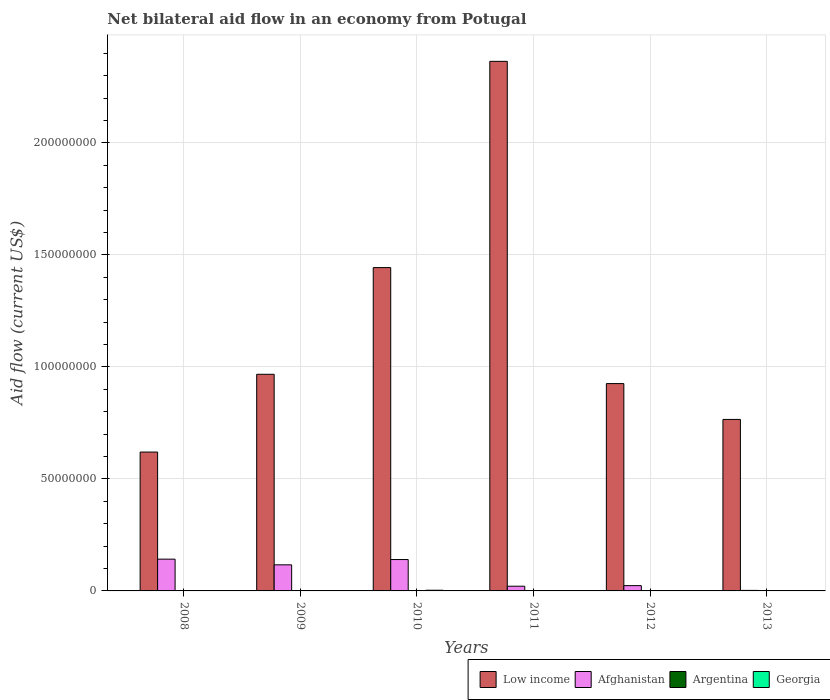How many different coloured bars are there?
Offer a very short reply. 4. Are the number of bars on each tick of the X-axis equal?
Ensure brevity in your answer.  Yes. How many bars are there on the 1st tick from the right?
Make the answer very short. 4. Across all years, what is the maximum net bilateral aid flow in Low income?
Ensure brevity in your answer.  2.36e+08. Across all years, what is the minimum net bilateral aid flow in Afghanistan?
Provide a short and direct response. 2.30e+05. In which year was the net bilateral aid flow in Low income maximum?
Your response must be concise. 2011. In which year was the net bilateral aid flow in Georgia minimum?
Your answer should be compact. 2012. What is the total net bilateral aid flow in Afghanistan in the graph?
Offer a very short reply. 4.45e+07. What is the difference between the net bilateral aid flow in Afghanistan in 2008 and that in 2013?
Offer a very short reply. 1.40e+07. What is the difference between the net bilateral aid flow in Georgia in 2012 and the net bilateral aid flow in Low income in 2013?
Offer a very short reply. -7.65e+07. What is the average net bilateral aid flow in Afghanistan per year?
Offer a terse response. 7.42e+06. In the year 2012, what is the difference between the net bilateral aid flow in Low income and net bilateral aid flow in Afghanistan?
Ensure brevity in your answer.  9.02e+07. What is the ratio of the net bilateral aid flow in Argentina in 2009 to that in 2010?
Keep it short and to the point. 2.25. What is the difference between the highest and the second highest net bilateral aid flow in Low income?
Your answer should be compact. 9.20e+07. What is the difference between the highest and the lowest net bilateral aid flow in Argentina?
Your answer should be very brief. 8.00e+04. What does the 4th bar from the left in 2010 represents?
Provide a succinct answer. Georgia. What does the 1st bar from the right in 2010 represents?
Your answer should be compact. Georgia. Are all the bars in the graph horizontal?
Your response must be concise. No. How many years are there in the graph?
Offer a very short reply. 6. Does the graph contain any zero values?
Provide a succinct answer. No. Does the graph contain grids?
Offer a very short reply. Yes. Where does the legend appear in the graph?
Your answer should be very brief. Bottom right. What is the title of the graph?
Provide a short and direct response. Net bilateral aid flow in an economy from Potugal. Does "Aruba" appear as one of the legend labels in the graph?
Make the answer very short. No. What is the label or title of the Y-axis?
Your answer should be very brief. Aid flow (current US$). What is the Aid flow (current US$) in Low income in 2008?
Give a very brief answer. 6.20e+07. What is the Aid flow (current US$) in Afghanistan in 2008?
Give a very brief answer. 1.42e+07. What is the Aid flow (current US$) of Argentina in 2008?
Your answer should be compact. 1.20e+05. What is the Aid flow (current US$) of Georgia in 2008?
Offer a terse response. 1.00e+05. What is the Aid flow (current US$) in Low income in 2009?
Keep it short and to the point. 9.67e+07. What is the Aid flow (current US$) of Afghanistan in 2009?
Your answer should be compact. 1.16e+07. What is the Aid flow (current US$) of Low income in 2010?
Keep it short and to the point. 1.44e+08. What is the Aid flow (current US$) of Afghanistan in 2010?
Your answer should be very brief. 1.40e+07. What is the Aid flow (current US$) in Argentina in 2010?
Provide a succinct answer. 4.00e+04. What is the Aid flow (current US$) of Georgia in 2010?
Your answer should be very brief. 3.00e+05. What is the Aid flow (current US$) in Low income in 2011?
Make the answer very short. 2.36e+08. What is the Aid flow (current US$) in Afghanistan in 2011?
Provide a succinct answer. 2.10e+06. What is the Aid flow (current US$) of Argentina in 2011?
Your answer should be very brief. 1.00e+05. What is the Aid flow (current US$) of Georgia in 2011?
Provide a short and direct response. 1.00e+05. What is the Aid flow (current US$) in Low income in 2012?
Your response must be concise. 9.25e+07. What is the Aid flow (current US$) of Afghanistan in 2012?
Provide a short and direct response. 2.36e+06. What is the Aid flow (current US$) of Georgia in 2012?
Keep it short and to the point. 5.00e+04. What is the Aid flow (current US$) of Low income in 2013?
Offer a very short reply. 7.65e+07. What is the Aid flow (current US$) in Afghanistan in 2013?
Your answer should be compact. 2.30e+05. What is the Aid flow (current US$) of Argentina in 2013?
Your response must be concise. 1.20e+05. Across all years, what is the maximum Aid flow (current US$) of Low income?
Provide a short and direct response. 2.36e+08. Across all years, what is the maximum Aid flow (current US$) of Afghanistan?
Give a very brief answer. 1.42e+07. Across all years, what is the maximum Aid flow (current US$) in Argentina?
Offer a very short reply. 1.20e+05. Across all years, what is the minimum Aid flow (current US$) of Low income?
Offer a very short reply. 6.20e+07. Across all years, what is the minimum Aid flow (current US$) in Afghanistan?
Offer a very short reply. 2.30e+05. Across all years, what is the minimum Aid flow (current US$) of Argentina?
Your answer should be compact. 4.00e+04. What is the total Aid flow (current US$) of Low income in the graph?
Give a very brief answer. 7.08e+08. What is the total Aid flow (current US$) of Afghanistan in the graph?
Your answer should be very brief. 4.45e+07. What is the total Aid flow (current US$) of Georgia in the graph?
Your response must be concise. 8.10e+05. What is the difference between the Aid flow (current US$) in Low income in 2008 and that in 2009?
Offer a very short reply. -3.47e+07. What is the difference between the Aid flow (current US$) in Afghanistan in 2008 and that in 2009?
Ensure brevity in your answer.  2.54e+06. What is the difference between the Aid flow (current US$) of Argentina in 2008 and that in 2009?
Ensure brevity in your answer.  3.00e+04. What is the difference between the Aid flow (current US$) in Low income in 2008 and that in 2010?
Your answer should be very brief. -8.23e+07. What is the difference between the Aid flow (current US$) of Georgia in 2008 and that in 2010?
Give a very brief answer. -2.00e+05. What is the difference between the Aid flow (current US$) of Low income in 2008 and that in 2011?
Offer a very short reply. -1.74e+08. What is the difference between the Aid flow (current US$) of Afghanistan in 2008 and that in 2011?
Offer a terse response. 1.21e+07. What is the difference between the Aid flow (current US$) in Argentina in 2008 and that in 2011?
Your answer should be compact. 2.00e+04. What is the difference between the Aid flow (current US$) in Georgia in 2008 and that in 2011?
Offer a very short reply. 0. What is the difference between the Aid flow (current US$) of Low income in 2008 and that in 2012?
Keep it short and to the point. -3.06e+07. What is the difference between the Aid flow (current US$) in Afghanistan in 2008 and that in 2012?
Make the answer very short. 1.18e+07. What is the difference between the Aid flow (current US$) in Argentina in 2008 and that in 2012?
Your response must be concise. 4.00e+04. What is the difference between the Aid flow (current US$) in Low income in 2008 and that in 2013?
Offer a very short reply. -1.46e+07. What is the difference between the Aid flow (current US$) of Afghanistan in 2008 and that in 2013?
Your answer should be very brief. 1.40e+07. What is the difference between the Aid flow (current US$) in Argentina in 2008 and that in 2013?
Give a very brief answer. 0. What is the difference between the Aid flow (current US$) in Low income in 2009 and that in 2010?
Keep it short and to the point. -4.76e+07. What is the difference between the Aid flow (current US$) in Afghanistan in 2009 and that in 2010?
Offer a terse response. -2.37e+06. What is the difference between the Aid flow (current US$) of Low income in 2009 and that in 2011?
Your answer should be very brief. -1.40e+08. What is the difference between the Aid flow (current US$) in Afghanistan in 2009 and that in 2011?
Your answer should be very brief. 9.54e+06. What is the difference between the Aid flow (current US$) of Argentina in 2009 and that in 2011?
Your answer should be compact. -10000. What is the difference between the Aid flow (current US$) of Low income in 2009 and that in 2012?
Give a very brief answer. 4.15e+06. What is the difference between the Aid flow (current US$) of Afghanistan in 2009 and that in 2012?
Offer a very short reply. 9.28e+06. What is the difference between the Aid flow (current US$) of Low income in 2009 and that in 2013?
Ensure brevity in your answer.  2.02e+07. What is the difference between the Aid flow (current US$) of Afghanistan in 2009 and that in 2013?
Keep it short and to the point. 1.14e+07. What is the difference between the Aid flow (current US$) in Argentina in 2009 and that in 2013?
Give a very brief answer. -3.00e+04. What is the difference between the Aid flow (current US$) of Georgia in 2009 and that in 2013?
Ensure brevity in your answer.  -4.00e+04. What is the difference between the Aid flow (current US$) of Low income in 2010 and that in 2011?
Make the answer very short. -9.20e+07. What is the difference between the Aid flow (current US$) in Afghanistan in 2010 and that in 2011?
Provide a short and direct response. 1.19e+07. What is the difference between the Aid flow (current US$) in Argentina in 2010 and that in 2011?
Your answer should be compact. -6.00e+04. What is the difference between the Aid flow (current US$) in Low income in 2010 and that in 2012?
Provide a succinct answer. 5.18e+07. What is the difference between the Aid flow (current US$) of Afghanistan in 2010 and that in 2012?
Keep it short and to the point. 1.16e+07. What is the difference between the Aid flow (current US$) in Argentina in 2010 and that in 2012?
Make the answer very short. -4.00e+04. What is the difference between the Aid flow (current US$) in Low income in 2010 and that in 2013?
Provide a short and direct response. 6.78e+07. What is the difference between the Aid flow (current US$) in Afghanistan in 2010 and that in 2013?
Your answer should be compact. 1.38e+07. What is the difference between the Aid flow (current US$) of Georgia in 2010 and that in 2013?
Make the answer very short. 1.50e+05. What is the difference between the Aid flow (current US$) in Low income in 2011 and that in 2012?
Your answer should be very brief. 1.44e+08. What is the difference between the Aid flow (current US$) in Afghanistan in 2011 and that in 2012?
Make the answer very short. -2.60e+05. What is the difference between the Aid flow (current US$) of Georgia in 2011 and that in 2012?
Give a very brief answer. 5.00e+04. What is the difference between the Aid flow (current US$) in Low income in 2011 and that in 2013?
Keep it short and to the point. 1.60e+08. What is the difference between the Aid flow (current US$) of Afghanistan in 2011 and that in 2013?
Your response must be concise. 1.87e+06. What is the difference between the Aid flow (current US$) in Georgia in 2011 and that in 2013?
Give a very brief answer. -5.00e+04. What is the difference between the Aid flow (current US$) in Low income in 2012 and that in 2013?
Make the answer very short. 1.60e+07. What is the difference between the Aid flow (current US$) of Afghanistan in 2012 and that in 2013?
Provide a short and direct response. 2.13e+06. What is the difference between the Aid flow (current US$) of Argentina in 2012 and that in 2013?
Keep it short and to the point. -4.00e+04. What is the difference between the Aid flow (current US$) of Low income in 2008 and the Aid flow (current US$) of Afghanistan in 2009?
Your response must be concise. 5.03e+07. What is the difference between the Aid flow (current US$) of Low income in 2008 and the Aid flow (current US$) of Argentina in 2009?
Offer a very short reply. 6.19e+07. What is the difference between the Aid flow (current US$) of Low income in 2008 and the Aid flow (current US$) of Georgia in 2009?
Ensure brevity in your answer.  6.19e+07. What is the difference between the Aid flow (current US$) in Afghanistan in 2008 and the Aid flow (current US$) in Argentina in 2009?
Your response must be concise. 1.41e+07. What is the difference between the Aid flow (current US$) of Afghanistan in 2008 and the Aid flow (current US$) of Georgia in 2009?
Make the answer very short. 1.41e+07. What is the difference between the Aid flow (current US$) of Low income in 2008 and the Aid flow (current US$) of Afghanistan in 2010?
Your answer should be very brief. 4.80e+07. What is the difference between the Aid flow (current US$) in Low income in 2008 and the Aid flow (current US$) in Argentina in 2010?
Your response must be concise. 6.19e+07. What is the difference between the Aid flow (current US$) in Low income in 2008 and the Aid flow (current US$) in Georgia in 2010?
Offer a very short reply. 6.17e+07. What is the difference between the Aid flow (current US$) in Afghanistan in 2008 and the Aid flow (current US$) in Argentina in 2010?
Provide a short and direct response. 1.41e+07. What is the difference between the Aid flow (current US$) of Afghanistan in 2008 and the Aid flow (current US$) of Georgia in 2010?
Ensure brevity in your answer.  1.39e+07. What is the difference between the Aid flow (current US$) in Argentina in 2008 and the Aid flow (current US$) in Georgia in 2010?
Your answer should be compact. -1.80e+05. What is the difference between the Aid flow (current US$) in Low income in 2008 and the Aid flow (current US$) in Afghanistan in 2011?
Ensure brevity in your answer.  5.99e+07. What is the difference between the Aid flow (current US$) of Low income in 2008 and the Aid flow (current US$) of Argentina in 2011?
Offer a very short reply. 6.19e+07. What is the difference between the Aid flow (current US$) in Low income in 2008 and the Aid flow (current US$) in Georgia in 2011?
Make the answer very short. 6.19e+07. What is the difference between the Aid flow (current US$) of Afghanistan in 2008 and the Aid flow (current US$) of Argentina in 2011?
Give a very brief answer. 1.41e+07. What is the difference between the Aid flow (current US$) of Afghanistan in 2008 and the Aid flow (current US$) of Georgia in 2011?
Make the answer very short. 1.41e+07. What is the difference between the Aid flow (current US$) of Low income in 2008 and the Aid flow (current US$) of Afghanistan in 2012?
Make the answer very short. 5.96e+07. What is the difference between the Aid flow (current US$) of Low income in 2008 and the Aid flow (current US$) of Argentina in 2012?
Offer a terse response. 6.19e+07. What is the difference between the Aid flow (current US$) in Low income in 2008 and the Aid flow (current US$) in Georgia in 2012?
Your response must be concise. 6.19e+07. What is the difference between the Aid flow (current US$) of Afghanistan in 2008 and the Aid flow (current US$) of Argentina in 2012?
Keep it short and to the point. 1.41e+07. What is the difference between the Aid flow (current US$) in Afghanistan in 2008 and the Aid flow (current US$) in Georgia in 2012?
Make the answer very short. 1.41e+07. What is the difference between the Aid flow (current US$) of Low income in 2008 and the Aid flow (current US$) of Afghanistan in 2013?
Provide a succinct answer. 6.18e+07. What is the difference between the Aid flow (current US$) in Low income in 2008 and the Aid flow (current US$) in Argentina in 2013?
Your answer should be very brief. 6.19e+07. What is the difference between the Aid flow (current US$) of Low income in 2008 and the Aid flow (current US$) of Georgia in 2013?
Provide a short and direct response. 6.18e+07. What is the difference between the Aid flow (current US$) of Afghanistan in 2008 and the Aid flow (current US$) of Argentina in 2013?
Offer a very short reply. 1.41e+07. What is the difference between the Aid flow (current US$) of Afghanistan in 2008 and the Aid flow (current US$) of Georgia in 2013?
Your answer should be very brief. 1.40e+07. What is the difference between the Aid flow (current US$) in Low income in 2009 and the Aid flow (current US$) in Afghanistan in 2010?
Ensure brevity in your answer.  8.27e+07. What is the difference between the Aid flow (current US$) of Low income in 2009 and the Aid flow (current US$) of Argentina in 2010?
Give a very brief answer. 9.66e+07. What is the difference between the Aid flow (current US$) of Low income in 2009 and the Aid flow (current US$) of Georgia in 2010?
Provide a short and direct response. 9.64e+07. What is the difference between the Aid flow (current US$) of Afghanistan in 2009 and the Aid flow (current US$) of Argentina in 2010?
Make the answer very short. 1.16e+07. What is the difference between the Aid flow (current US$) of Afghanistan in 2009 and the Aid flow (current US$) of Georgia in 2010?
Provide a succinct answer. 1.13e+07. What is the difference between the Aid flow (current US$) in Low income in 2009 and the Aid flow (current US$) in Afghanistan in 2011?
Make the answer very short. 9.46e+07. What is the difference between the Aid flow (current US$) of Low income in 2009 and the Aid flow (current US$) of Argentina in 2011?
Give a very brief answer. 9.66e+07. What is the difference between the Aid flow (current US$) of Low income in 2009 and the Aid flow (current US$) of Georgia in 2011?
Offer a very short reply. 9.66e+07. What is the difference between the Aid flow (current US$) in Afghanistan in 2009 and the Aid flow (current US$) in Argentina in 2011?
Provide a short and direct response. 1.15e+07. What is the difference between the Aid flow (current US$) of Afghanistan in 2009 and the Aid flow (current US$) of Georgia in 2011?
Your response must be concise. 1.15e+07. What is the difference between the Aid flow (current US$) in Argentina in 2009 and the Aid flow (current US$) in Georgia in 2011?
Ensure brevity in your answer.  -10000. What is the difference between the Aid flow (current US$) in Low income in 2009 and the Aid flow (current US$) in Afghanistan in 2012?
Your answer should be very brief. 9.43e+07. What is the difference between the Aid flow (current US$) of Low income in 2009 and the Aid flow (current US$) of Argentina in 2012?
Give a very brief answer. 9.66e+07. What is the difference between the Aid flow (current US$) in Low income in 2009 and the Aid flow (current US$) in Georgia in 2012?
Provide a short and direct response. 9.66e+07. What is the difference between the Aid flow (current US$) in Afghanistan in 2009 and the Aid flow (current US$) in Argentina in 2012?
Ensure brevity in your answer.  1.16e+07. What is the difference between the Aid flow (current US$) of Afghanistan in 2009 and the Aid flow (current US$) of Georgia in 2012?
Your answer should be compact. 1.16e+07. What is the difference between the Aid flow (current US$) in Argentina in 2009 and the Aid flow (current US$) in Georgia in 2012?
Provide a succinct answer. 4.00e+04. What is the difference between the Aid flow (current US$) of Low income in 2009 and the Aid flow (current US$) of Afghanistan in 2013?
Provide a short and direct response. 9.65e+07. What is the difference between the Aid flow (current US$) in Low income in 2009 and the Aid flow (current US$) in Argentina in 2013?
Make the answer very short. 9.66e+07. What is the difference between the Aid flow (current US$) in Low income in 2009 and the Aid flow (current US$) in Georgia in 2013?
Offer a very short reply. 9.65e+07. What is the difference between the Aid flow (current US$) of Afghanistan in 2009 and the Aid flow (current US$) of Argentina in 2013?
Give a very brief answer. 1.15e+07. What is the difference between the Aid flow (current US$) of Afghanistan in 2009 and the Aid flow (current US$) of Georgia in 2013?
Your answer should be very brief. 1.15e+07. What is the difference between the Aid flow (current US$) of Argentina in 2009 and the Aid flow (current US$) of Georgia in 2013?
Provide a succinct answer. -6.00e+04. What is the difference between the Aid flow (current US$) in Low income in 2010 and the Aid flow (current US$) in Afghanistan in 2011?
Keep it short and to the point. 1.42e+08. What is the difference between the Aid flow (current US$) in Low income in 2010 and the Aid flow (current US$) in Argentina in 2011?
Provide a succinct answer. 1.44e+08. What is the difference between the Aid flow (current US$) in Low income in 2010 and the Aid flow (current US$) in Georgia in 2011?
Ensure brevity in your answer.  1.44e+08. What is the difference between the Aid flow (current US$) of Afghanistan in 2010 and the Aid flow (current US$) of Argentina in 2011?
Give a very brief answer. 1.39e+07. What is the difference between the Aid flow (current US$) of Afghanistan in 2010 and the Aid flow (current US$) of Georgia in 2011?
Make the answer very short. 1.39e+07. What is the difference between the Aid flow (current US$) in Argentina in 2010 and the Aid flow (current US$) in Georgia in 2011?
Offer a terse response. -6.00e+04. What is the difference between the Aid flow (current US$) in Low income in 2010 and the Aid flow (current US$) in Afghanistan in 2012?
Offer a terse response. 1.42e+08. What is the difference between the Aid flow (current US$) in Low income in 2010 and the Aid flow (current US$) in Argentina in 2012?
Provide a short and direct response. 1.44e+08. What is the difference between the Aid flow (current US$) in Low income in 2010 and the Aid flow (current US$) in Georgia in 2012?
Your answer should be compact. 1.44e+08. What is the difference between the Aid flow (current US$) of Afghanistan in 2010 and the Aid flow (current US$) of Argentina in 2012?
Your answer should be very brief. 1.39e+07. What is the difference between the Aid flow (current US$) in Afghanistan in 2010 and the Aid flow (current US$) in Georgia in 2012?
Your answer should be compact. 1.40e+07. What is the difference between the Aid flow (current US$) in Low income in 2010 and the Aid flow (current US$) in Afghanistan in 2013?
Offer a terse response. 1.44e+08. What is the difference between the Aid flow (current US$) of Low income in 2010 and the Aid flow (current US$) of Argentina in 2013?
Your answer should be very brief. 1.44e+08. What is the difference between the Aid flow (current US$) of Low income in 2010 and the Aid flow (current US$) of Georgia in 2013?
Give a very brief answer. 1.44e+08. What is the difference between the Aid flow (current US$) of Afghanistan in 2010 and the Aid flow (current US$) of Argentina in 2013?
Keep it short and to the point. 1.39e+07. What is the difference between the Aid flow (current US$) in Afghanistan in 2010 and the Aid flow (current US$) in Georgia in 2013?
Your response must be concise. 1.39e+07. What is the difference between the Aid flow (current US$) in Low income in 2011 and the Aid flow (current US$) in Afghanistan in 2012?
Offer a very short reply. 2.34e+08. What is the difference between the Aid flow (current US$) of Low income in 2011 and the Aid flow (current US$) of Argentina in 2012?
Provide a short and direct response. 2.36e+08. What is the difference between the Aid flow (current US$) of Low income in 2011 and the Aid flow (current US$) of Georgia in 2012?
Your answer should be very brief. 2.36e+08. What is the difference between the Aid flow (current US$) in Afghanistan in 2011 and the Aid flow (current US$) in Argentina in 2012?
Offer a very short reply. 2.02e+06. What is the difference between the Aid flow (current US$) in Afghanistan in 2011 and the Aid flow (current US$) in Georgia in 2012?
Make the answer very short. 2.05e+06. What is the difference between the Aid flow (current US$) in Low income in 2011 and the Aid flow (current US$) in Afghanistan in 2013?
Your response must be concise. 2.36e+08. What is the difference between the Aid flow (current US$) of Low income in 2011 and the Aid flow (current US$) of Argentina in 2013?
Provide a short and direct response. 2.36e+08. What is the difference between the Aid flow (current US$) of Low income in 2011 and the Aid flow (current US$) of Georgia in 2013?
Ensure brevity in your answer.  2.36e+08. What is the difference between the Aid flow (current US$) of Afghanistan in 2011 and the Aid flow (current US$) of Argentina in 2013?
Offer a terse response. 1.98e+06. What is the difference between the Aid flow (current US$) in Afghanistan in 2011 and the Aid flow (current US$) in Georgia in 2013?
Your answer should be very brief. 1.95e+06. What is the difference between the Aid flow (current US$) in Argentina in 2011 and the Aid flow (current US$) in Georgia in 2013?
Your answer should be compact. -5.00e+04. What is the difference between the Aid flow (current US$) of Low income in 2012 and the Aid flow (current US$) of Afghanistan in 2013?
Your response must be concise. 9.23e+07. What is the difference between the Aid flow (current US$) in Low income in 2012 and the Aid flow (current US$) in Argentina in 2013?
Your answer should be compact. 9.24e+07. What is the difference between the Aid flow (current US$) in Low income in 2012 and the Aid flow (current US$) in Georgia in 2013?
Your answer should be very brief. 9.24e+07. What is the difference between the Aid flow (current US$) in Afghanistan in 2012 and the Aid flow (current US$) in Argentina in 2013?
Your answer should be compact. 2.24e+06. What is the difference between the Aid flow (current US$) in Afghanistan in 2012 and the Aid flow (current US$) in Georgia in 2013?
Offer a very short reply. 2.21e+06. What is the difference between the Aid flow (current US$) of Argentina in 2012 and the Aid flow (current US$) of Georgia in 2013?
Keep it short and to the point. -7.00e+04. What is the average Aid flow (current US$) of Low income per year?
Ensure brevity in your answer.  1.18e+08. What is the average Aid flow (current US$) in Afghanistan per year?
Offer a terse response. 7.42e+06. What is the average Aid flow (current US$) of Argentina per year?
Ensure brevity in your answer.  9.17e+04. What is the average Aid flow (current US$) of Georgia per year?
Ensure brevity in your answer.  1.35e+05. In the year 2008, what is the difference between the Aid flow (current US$) in Low income and Aid flow (current US$) in Afghanistan?
Your answer should be compact. 4.78e+07. In the year 2008, what is the difference between the Aid flow (current US$) in Low income and Aid flow (current US$) in Argentina?
Your response must be concise. 6.19e+07. In the year 2008, what is the difference between the Aid flow (current US$) in Low income and Aid flow (current US$) in Georgia?
Give a very brief answer. 6.19e+07. In the year 2008, what is the difference between the Aid flow (current US$) of Afghanistan and Aid flow (current US$) of Argentina?
Provide a succinct answer. 1.41e+07. In the year 2008, what is the difference between the Aid flow (current US$) in Afghanistan and Aid flow (current US$) in Georgia?
Your answer should be compact. 1.41e+07. In the year 2009, what is the difference between the Aid flow (current US$) of Low income and Aid flow (current US$) of Afghanistan?
Offer a very short reply. 8.50e+07. In the year 2009, what is the difference between the Aid flow (current US$) of Low income and Aid flow (current US$) of Argentina?
Provide a short and direct response. 9.66e+07. In the year 2009, what is the difference between the Aid flow (current US$) of Low income and Aid flow (current US$) of Georgia?
Provide a short and direct response. 9.66e+07. In the year 2009, what is the difference between the Aid flow (current US$) of Afghanistan and Aid flow (current US$) of Argentina?
Your response must be concise. 1.16e+07. In the year 2009, what is the difference between the Aid flow (current US$) of Afghanistan and Aid flow (current US$) of Georgia?
Give a very brief answer. 1.15e+07. In the year 2010, what is the difference between the Aid flow (current US$) in Low income and Aid flow (current US$) in Afghanistan?
Offer a terse response. 1.30e+08. In the year 2010, what is the difference between the Aid flow (current US$) of Low income and Aid flow (current US$) of Argentina?
Your response must be concise. 1.44e+08. In the year 2010, what is the difference between the Aid flow (current US$) in Low income and Aid flow (current US$) in Georgia?
Ensure brevity in your answer.  1.44e+08. In the year 2010, what is the difference between the Aid flow (current US$) in Afghanistan and Aid flow (current US$) in Argentina?
Offer a terse response. 1.40e+07. In the year 2010, what is the difference between the Aid flow (current US$) of Afghanistan and Aid flow (current US$) of Georgia?
Give a very brief answer. 1.37e+07. In the year 2011, what is the difference between the Aid flow (current US$) of Low income and Aid flow (current US$) of Afghanistan?
Make the answer very short. 2.34e+08. In the year 2011, what is the difference between the Aid flow (current US$) of Low income and Aid flow (current US$) of Argentina?
Ensure brevity in your answer.  2.36e+08. In the year 2011, what is the difference between the Aid flow (current US$) in Low income and Aid flow (current US$) in Georgia?
Offer a terse response. 2.36e+08. In the year 2011, what is the difference between the Aid flow (current US$) of Afghanistan and Aid flow (current US$) of Georgia?
Provide a succinct answer. 2.00e+06. In the year 2011, what is the difference between the Aid flow (current US$) in Argentina and Aid flow (current US$) in Georgia?
Make the answer very short. 0. In the year 2012, what is the difference between the Aid flow (current US$) of Low income and Aid flow (current US$) of Afghanistan?
Your answer should be very brief. 9.02e+07. In the year 2012, what is the difference between the Aid flow (current US$) in Low income and Aid flow (current US$) in Argentina?
Give a very brief answer. 9.25e+07. In the year 2012, what is the difference between the Aid flow (current US$) of Low income and Aid flow (current US$) of Georgia?
Offer a terse response. 9.25e+07. In the year 2012, what is the difference between the Aid flow (current US$) of Afghanistan and Aid flow (current US$) of Argentina?
Your answer should be compact. 2.28e+06. In the year 2012, what is the difference between the Aid flow (current US$) of Afghanistan and Aid flow (current US$) of Georgia?
Offer a terse response. 2.31e+06. In the year 2012, what is the difference between the Aid flow (current US$) of Argentina and Aid flow (current US$) of Georgia?
Offer a very short reply. 3.00e+04. In the year 2013, what is the difference between the Aid flow (current US$) in Low income and Aid flow (current US$) in Afghanistan?
Provide a succinct answer. 7.63e+07. In the year 2013, what is the difference between the Aid flow (current US$) of Low income and Aid flow (current US$) of Argentina?
Keep it short and to the point. 7.64e+07. In the year 2013, what is the difference between the Aid flow (current US$) of Low income and Aid flow (current US$) of Georgia?
Offer a very short reply. 7.64e+07. In the year 2013, what is the difference between the Aid flow (current US$) of Afghanistan and Aid flow (current US$) of Georgia?
Your answer should be compact. 8.00e+04. What is the ratio of the Aid flow (current US$) in Low income in 2008 to that in 2009?
Your answer should be compact. 0.64. What is the ratio of the Aid flow (current US$) in Afghanistan in 2008 to that in 2009?
Make the answer very short. 1.22. What is the ratio of the Aid flow (current US$) of Georgia in 2008 to that in 2009?
Keep it short and to the point. 0.91. What is the ratio of the Aid flow (current US$) of Low income in 2008 to that in 2010?
Provide a short and direct response. 0.43. What is the ratio of the Aid flow (current US$) in Afghanistan in 2008 to that in 2010?
Provide a succinct answer. 1.01. What is the ratio of the Aid flow (current US$) in Argentina in 2008 to that in 2010?
Make the answer very short. 3. What is the ratio of the Aid flow (current US$) in Georgia in 2008 to that in 2010?
Provide a short and direct response. 0.33. What is the ratio of the Aid flow (current US$) of Low income in 2008 to that in 2011?
Your response must be concise. 0.26. What is the ratio of the Aid flow (current US$) in Afghanistan in 2008 to that in 2011?
Make the answer very short. 6.75. What is the ratio of the Aid flow (current US$) in Argentina in 2008 to that in 2011?
Give a very brief answer. 1.2. What is the ratio of the Aid flow (current US$) of Low income in 2008 to that in 2012?
Provide a succinct answer. 0.67. What is the ratio of the Aid flow (current US$) of Afghanistan in 2008 to that in 2012?
Provide a succinct answer. 6.01. What is the ratio of the Aid flow (current US$) of Low income in 2008 to that in 2013?
Provide a succinct answer. 0.81. What is the ratio of the Aid flow (current US$) in Afghanistan in 2008 to that in 2013?
Your answer should be very brief. 61.65. What is the ratio of the Aid flow (current US$) of Georgia in 2008 to that in 2013?
Keep it short and to the point. 0.67. What is the ratio of the Aid flow (current US$) in Low income in 2009 to that in 2010?
Keep it short and to the point. 0.67. What is the ratio of the Aid flow (current US$) of Afghanistan in 2009 to that in 2010?
Give a very brief answer. 0.83. What is the ratio of the Aid flow (current US$) in Argentina in 2009 to that in 2010?
Offer a terse response. 2.25. What is the ratio of the Aid flow (current US$) of Georgia in 2009 to that in 2010?
Offer a very short reply. 0.37. What is the ratio of the Aid flow (current US$) in Low income in 2009 to that in 2011?
Offer a terse response. 0.41. What is the ratio of the Aid flow (current US$) in Afghanistan in 2009 to that in 2011?
Make the answer very short. 5.54. What is the ratio of the Aid flow (current US$) of Low income in 2009 to that in 2012?
Offer a very short reply. 1.04. What is the ratio of the Aid flow (current US$) in Afghanistan in 2009 to that in 2012?
Give a very brief answer. 4.93. What is the ratio of the Aid flow (current US$) of Low income in 2009 to that in 2013?
Keep it short and to the point. 1.26. What is the ratio of the Aid flow (current US$) of Afghanistan in 2009 to that in 2013?
Provide a short and direct response. 50.61. What is the ratio of the Aid flow (current US$) in Argentina in 2009 to that in 2013?
Your response must be concise. 0.75. What is the ratio of the Aid flow (current US$) of Georgia in 2009 to that in 2013?
Your answer should be compact. 0.73. What is the ratio of the Aid flow (current US$) in Low income in 2010 to that in 2011?
Your answer should be very brief. 0.61. What is the ratio of the Aid flow (current US$) in Afghanistan in 2010 to that in 2011?
Give a very brief answer. 6.67. What is the ratio of the Aid flow (current US$) of Argentina in 2010 to that in 2011?
Your answer should be compact. 0.4. What is the ratio of the Aid flow (current US$) of Low income in 2010 to that in 2012?
Keep it short and to the point. 1.56. What is the ratio of the Aid flow (current US$) in Afghanistan in 2010 to that in 2012?
Offer a terse response. 5.94. What is the ratio of the Aid flow (current US$) of Low income in 2010 to that in 2013?
Give a very brief answer. 1.89. What is the ratio of the Aid flow (current US$) of Afghanistan in 2010 to that in 2013?
Provide a short and direct response. 60.91. What is the ratio of the Aid flow (current US$) in Argentina in 2010 to that in 2013?
Provide a short and direct response. 0.33. What is the ratio of the Aid flow (current US$) in Georgia in 2010 to that in 2013?
Keep it short and to the point. 2. What is the ratio of the Aid flow (current US$) of Low income in 2011 to that in 2012?
Your answer should be compact. 2.55. What is the ratio of the Aid flow (current US$) in Afghanistan in 2011 to that in 2012?
Offer a very short reply. 0.89. What is the ratio of the Aid flow (current US$) in Argentina in 2011 to that in 2012?
Give a very brief answer. 1.25. What is the ratio of the Aid flow (current US$) in Low income in 2011 to that in 2013?
Make the answer very short. 3.09. What is the ratio of the Aid flow (current US$) in Afghanistan in 2011 to that in 2013?
Your answer should be compact. 9.13. What is the ratio of the Aid flow (current US$) of Low income in 2012 to that in 2013?
Keep it short and to the point. 1.21. What is the ratio of the Aid flow (current US$) in Afghanistan in 2012 to that in 2013?
Ensure brevity in your answer.  10.26. What is the ratio of the Aid flow (current US$) of Argentina in 2012 to that in 2013?
Keep it short and to the point. 0.67. What is the ratio of the Aid flow (current US$) of Georgia in 2012 to that in 2013?
Offer a terse response. 0.33. What is the difference between the highest and the second highest Aid flow (current US$) of Low income?
Your answer should be very brief. 9.20e+07. What is the difference between the highest and the second highest Aid flow (current US$) in Georgia?
Your answer should be very brief. 1.50e+05. What is the difference between the highest and the lowest Aid flow (current US$) in Low income?
Your response must be concise. 1.74e+08. What is the difference between the highest and the lowest Aid flow (current US$) in Afghanistan?
Your answer should be very brief. 1.40e+07. What is the difference between the highest and the lowest Aid flow (current US$) of Georgia?
Your answer should be compact. 2.50e+05. 